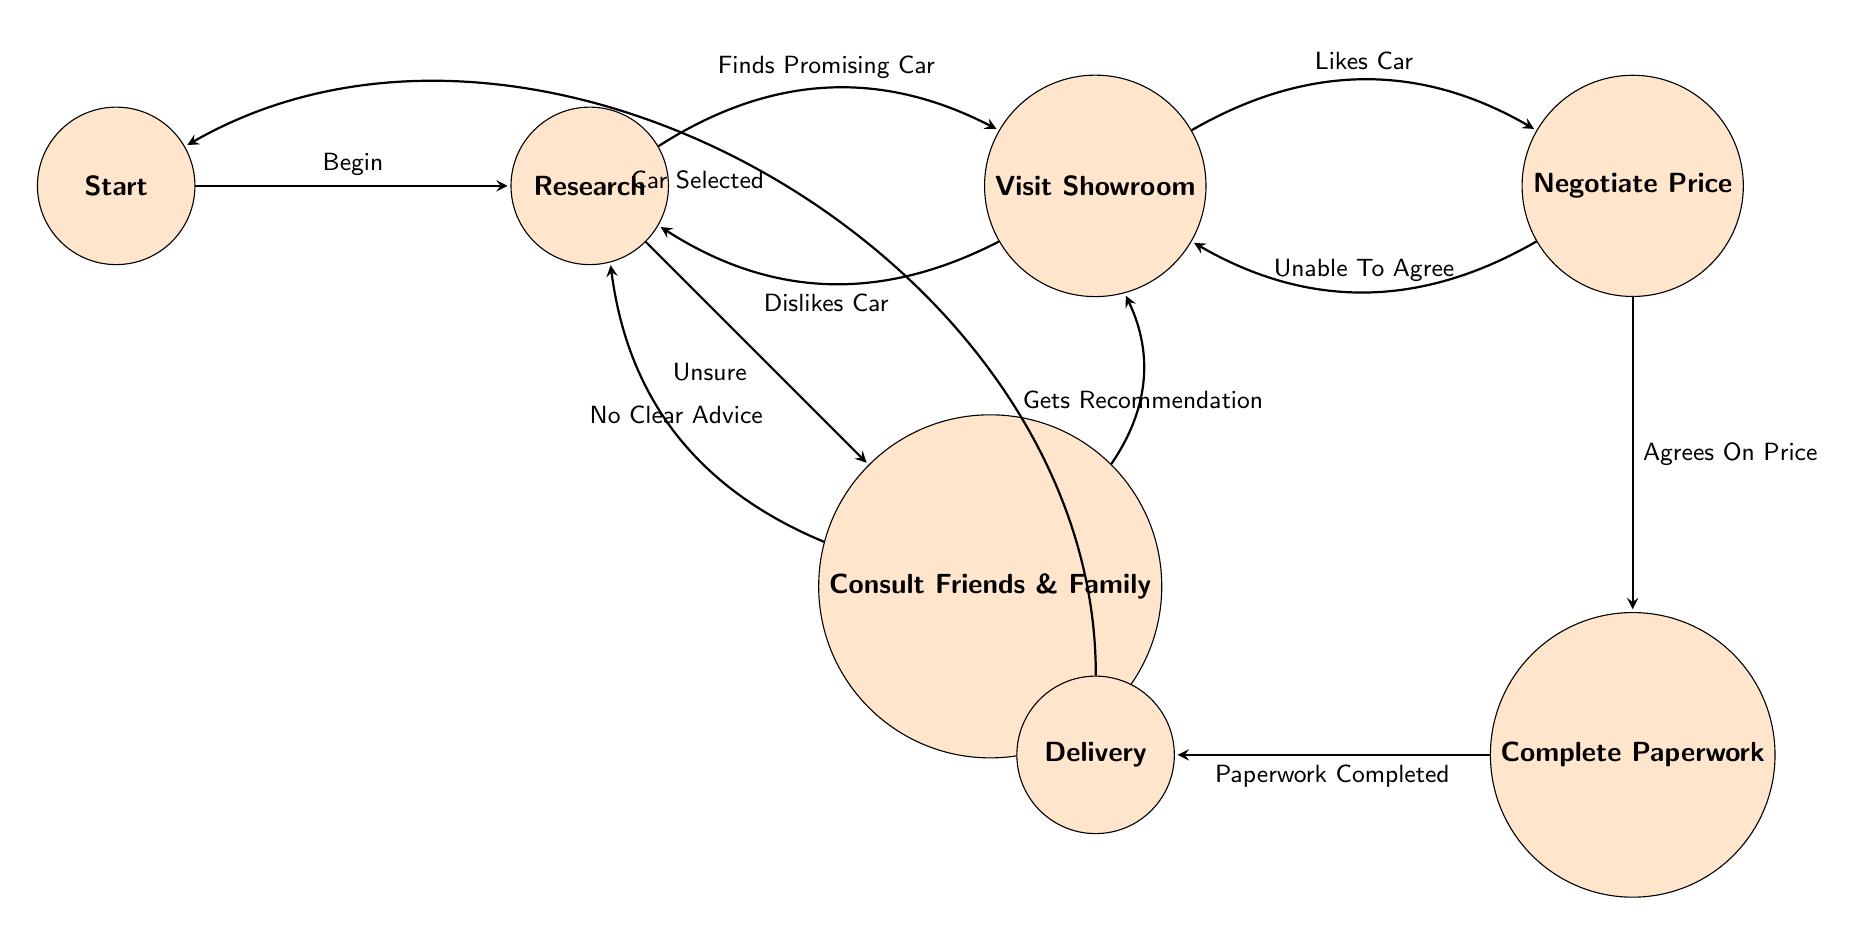What is the initial state of the vehicle purchase process? The initial state where the user begins is labeled as "Start," which is the starting point of the flow in the diagram.
Answer: Start How many transitions are available from the "Research" state? In the "Research" state, there are two transitions: "Finds Promising Car" leading to "Visit Showroom" and "Unsure" leading to "Consult Friends & Family." Thus, the total number of transitions is two.
Answer: 2 What happens if the user dislikes the car while visiting the showroom? If the user dislikes the car during the "Visit Showroom," the transition leads back to the "Research" state, indicating the user will engage in more research.
Answer: Research Which state follows "Negotiate Price" if the user agrees on the price? If the user agrees on the price during the "Negotiate Price" state, the next state is "Complete Paperwork," where the necessary documentation begins.
Answer: Complete Paperwork What is the final state of the purchase process? The completion of the process is defined as the "Delivery" state, where the user takes delivery of the new car, marking the end of the purchase journey.
Answer: Delivery If the user is unsure after research, which state do they transition to? If the user feels unsure after conducting their research, they transition to "Consult Friends & Family," seeking advice from their network for clarity.
Answer: Consult Friends & Family What does the "Delivery" state transition back to? Once the delivery of the car is complete, the "Delivery" state transitions back to the "Start" state as the process can initiate anew or conclude entirely.
Answer: Start What is the first transition that occurs after the "Start" state? The first transition from the "Start" state is labeled "Begin," which leads directly to the "Research" state, initiating the vehicle purchase process.
Answer: Research How does one reach the "Complete Paperwork" from "Visit Showroom"? To reach "Complete Paperwork" from "Visit Showroom," the user must transition through "Negotiate Price" after liking the car, resulting in an agreement on the price.
Answer: Negotiate Price 